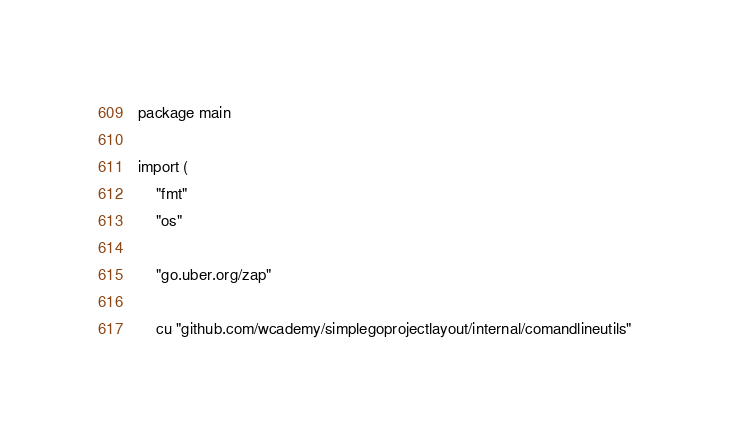Convert code to text. <code><loc_0><loc_0><loc_500><loc_500><_Go_>package main

import (
	"fmt"
	"os"

	"go.uber.org/zap"

	cu "github.com/wcademy/simplegoprojectlayout/internal/comandlineutils"</code> 